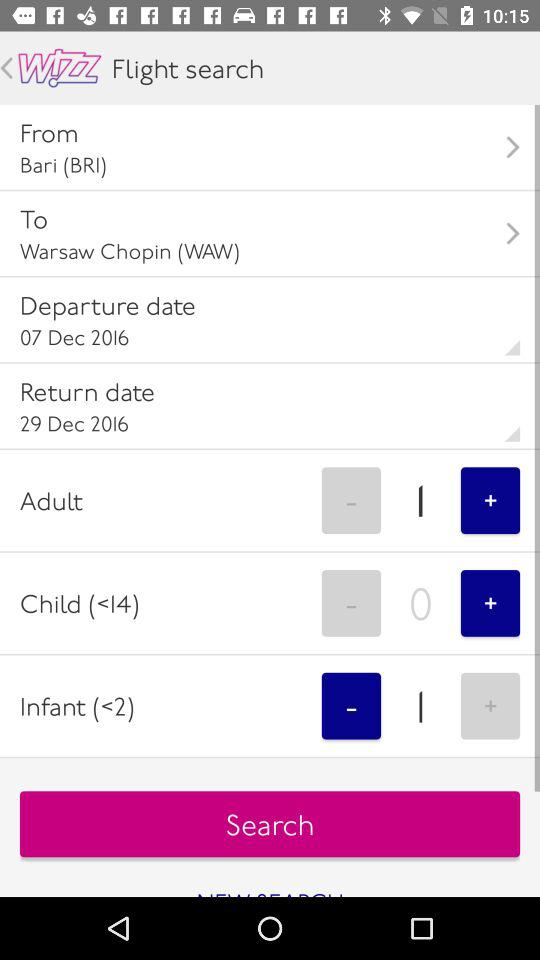How many infants do you have? You have 1 infant. 